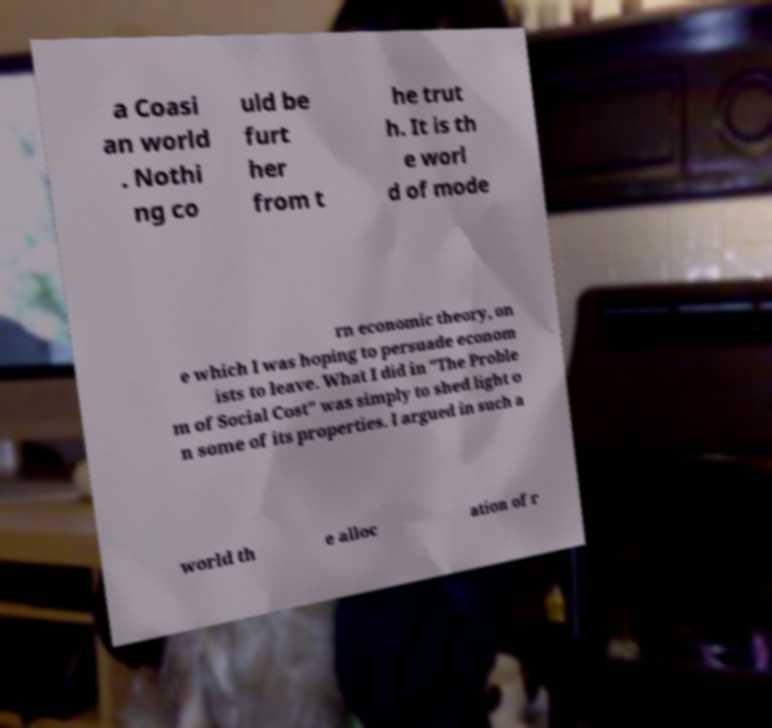Could you assist in decoding the text presented in this image and type it out clearly? a Coasi an world . Nothi ng co uld be furt her from t he trut h. It is th e worl d of mode rn economic theory, on e which I was hoping to persuade econom ists to leave. What I did in "The Proble m of Social Cost" was simply to shed light o n some of its properties. I argued in such a world th e alloc ation of r 